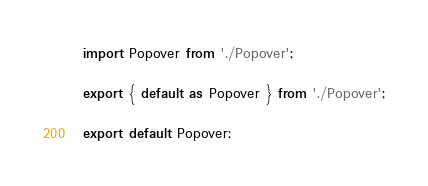<code> <loc_0><loc_0><loc_500><loc_500><_TypeScript_>import Popover from './Popover';

export { default as Popover } from './Popover';

export default Popover;
</code> 